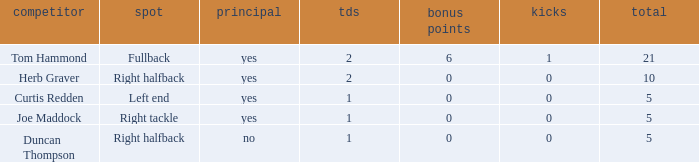Help me parse the entirety of this table. {'header': ['competitor', 'spot', 'principal', 'tds', 'bonus points', 'kicks', 'total'], 'rows': [['Tom Hammond', 'Fullback', 'yes', '2', '6', '1', '21'], ['Herb Graver', 'Right halfback', 'yes', '2', '0', '0', '10'], ['Curtis Redden', 'Left end', 'yes', '1', '0', '0', '5'], ['Joe Maddock', 'Right tackle', 'yes', '1', '0', '0', '5'], ['Duncan Thompson', 'Right halfback', 'no', '1', '0', '0', '5']]} Name the fewest touchdowns 1.0. 